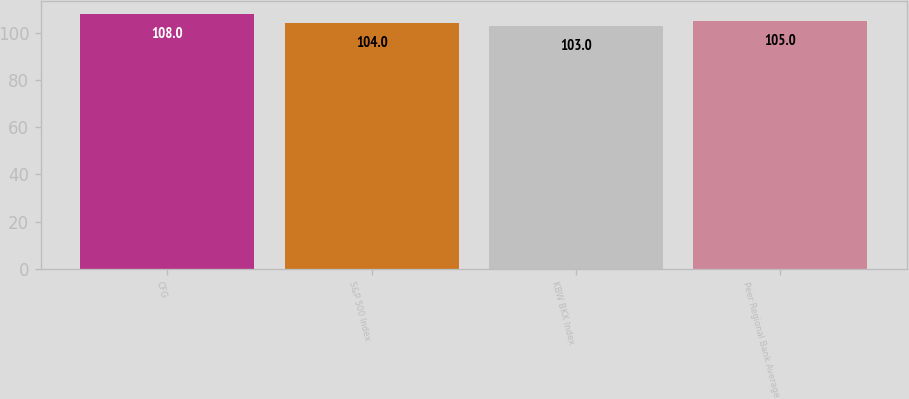Convert chart to OTSL. <chart><loc_0><loc_0><loc_500><loc_500><bar_chart><fcel>CFG<fcel>S&P 500 Index<fcel>KBW BKX Index<fcel>Peer Regional Bank Average<nl><fcel>108<fcel>104<fcel>103<fcel>105<nl></chart> 